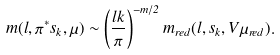Convert formula to latex. <formula><loc_0><loc_0><loc_500><loc_500>m ( l , \pi ^ { * } s _ { k } , \mu ) \sim \left ( \frac { l k } { \pi } \right ) ^ { - m / 2 } m _ { r e d } ( l , s _ { k } , V \mu _ { r e d } ) .</formula> 